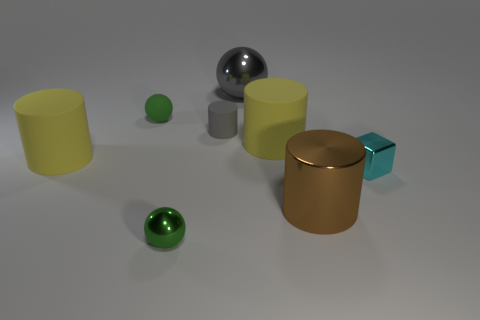Can you describe the lighting and shadows in the image? Certainly! The image is illuminated by a soft, diffuse light source that seems to be positioned above and out of the direct scene. This lighting casts gentle shadows on the ground that are elongated diagonally to the right, suggesting the light source is to the left. The objects have subtle highlights and soft shadows which contribute to the sense of depth and volume. The smooth surfaces of the objects, particularly the metallic ones, also reflect light and their surroundings, thus enhancing the overall three-dimensional effect. 